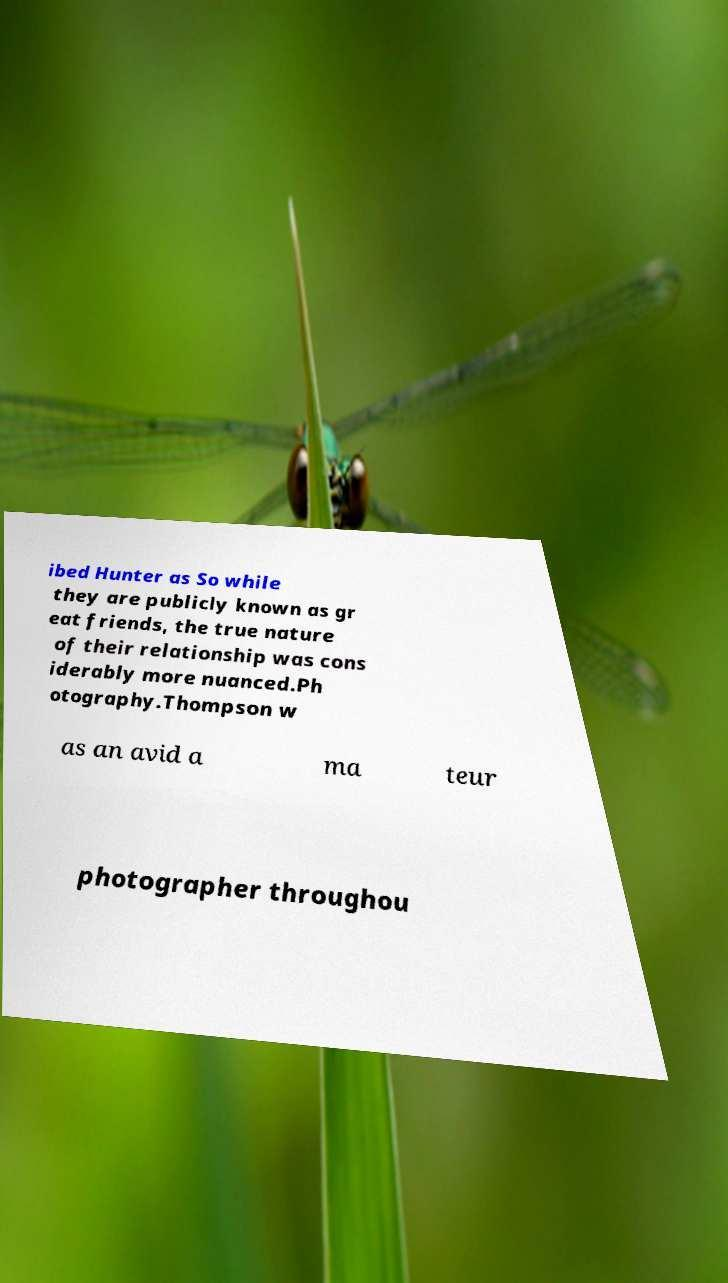I need the written content from this picture converted into text. Can you do that? ibed Hunter as So while they are publicly known as gr eat friends, the true nature of their relationship was cons iderably more nuanced.Ph otography.Thompson w as an avid a ma teur photographer throughou 